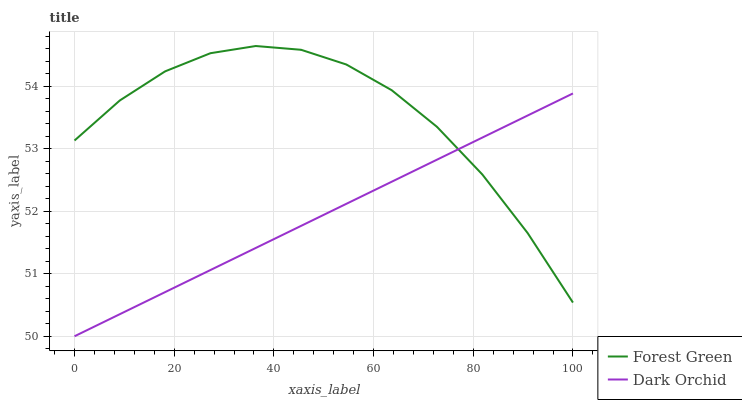Does Dark Orchid have the minimum area under the curve?
Answer yes or no. Yes. Does Forest Green have the maximum area under the curve?
Answer yes or no. Yes. Does Dark Orchid have the maximum area under the curve?
Answer yes or no. No. Is Dark Orchid the smoothest?
Answer yes or no. Yes. Is Forest Green the roughest?
Answer yes or no. Yes. Is Dark Orchid the roughest?
Answer yes or no. No. Does Dark Orchid have the lowest value?
Answer yes or no. Yes. Does Forest Green have the highest value?
Answer yes or no. Yes. Does Dark Orchid have the highest value?
Answer yes or no. No. Does Forest Green intersect Dark Orchid?
Answer yes or no. Yes. Is Forest Green less than Dark Orchid?
Answer yes or no. No. Is Forest Green greater than Dark Orchid?
Answer yes or no. No. 